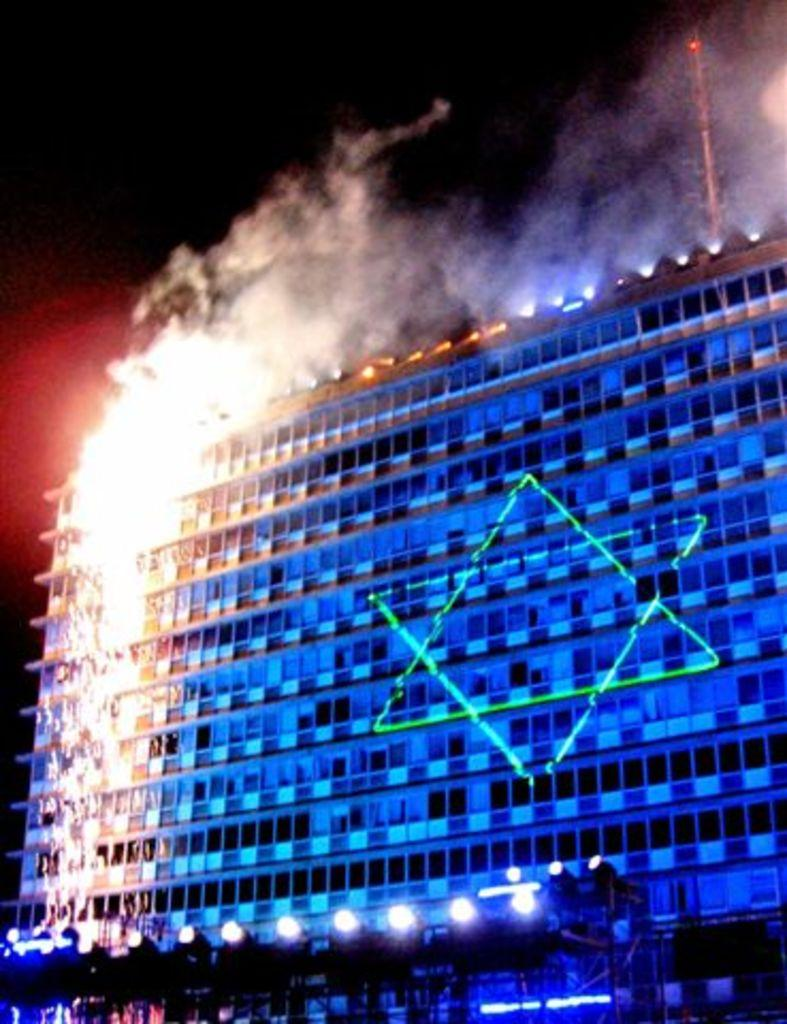What type of structure is present in the image? There is a building in the image. What is located in front of the building? There are lights in front of the building. What can be seen in the air in the image? Smoke is visible in the image. What feature is present on the top side of the building? There is a tower on the top side of the image. What type of cord is hanging from the tower in the image? There is no cord hanging from the tower in the image. What color is the vest worn by the person standing next to the building? There is no person wearing a vest present in the image. 